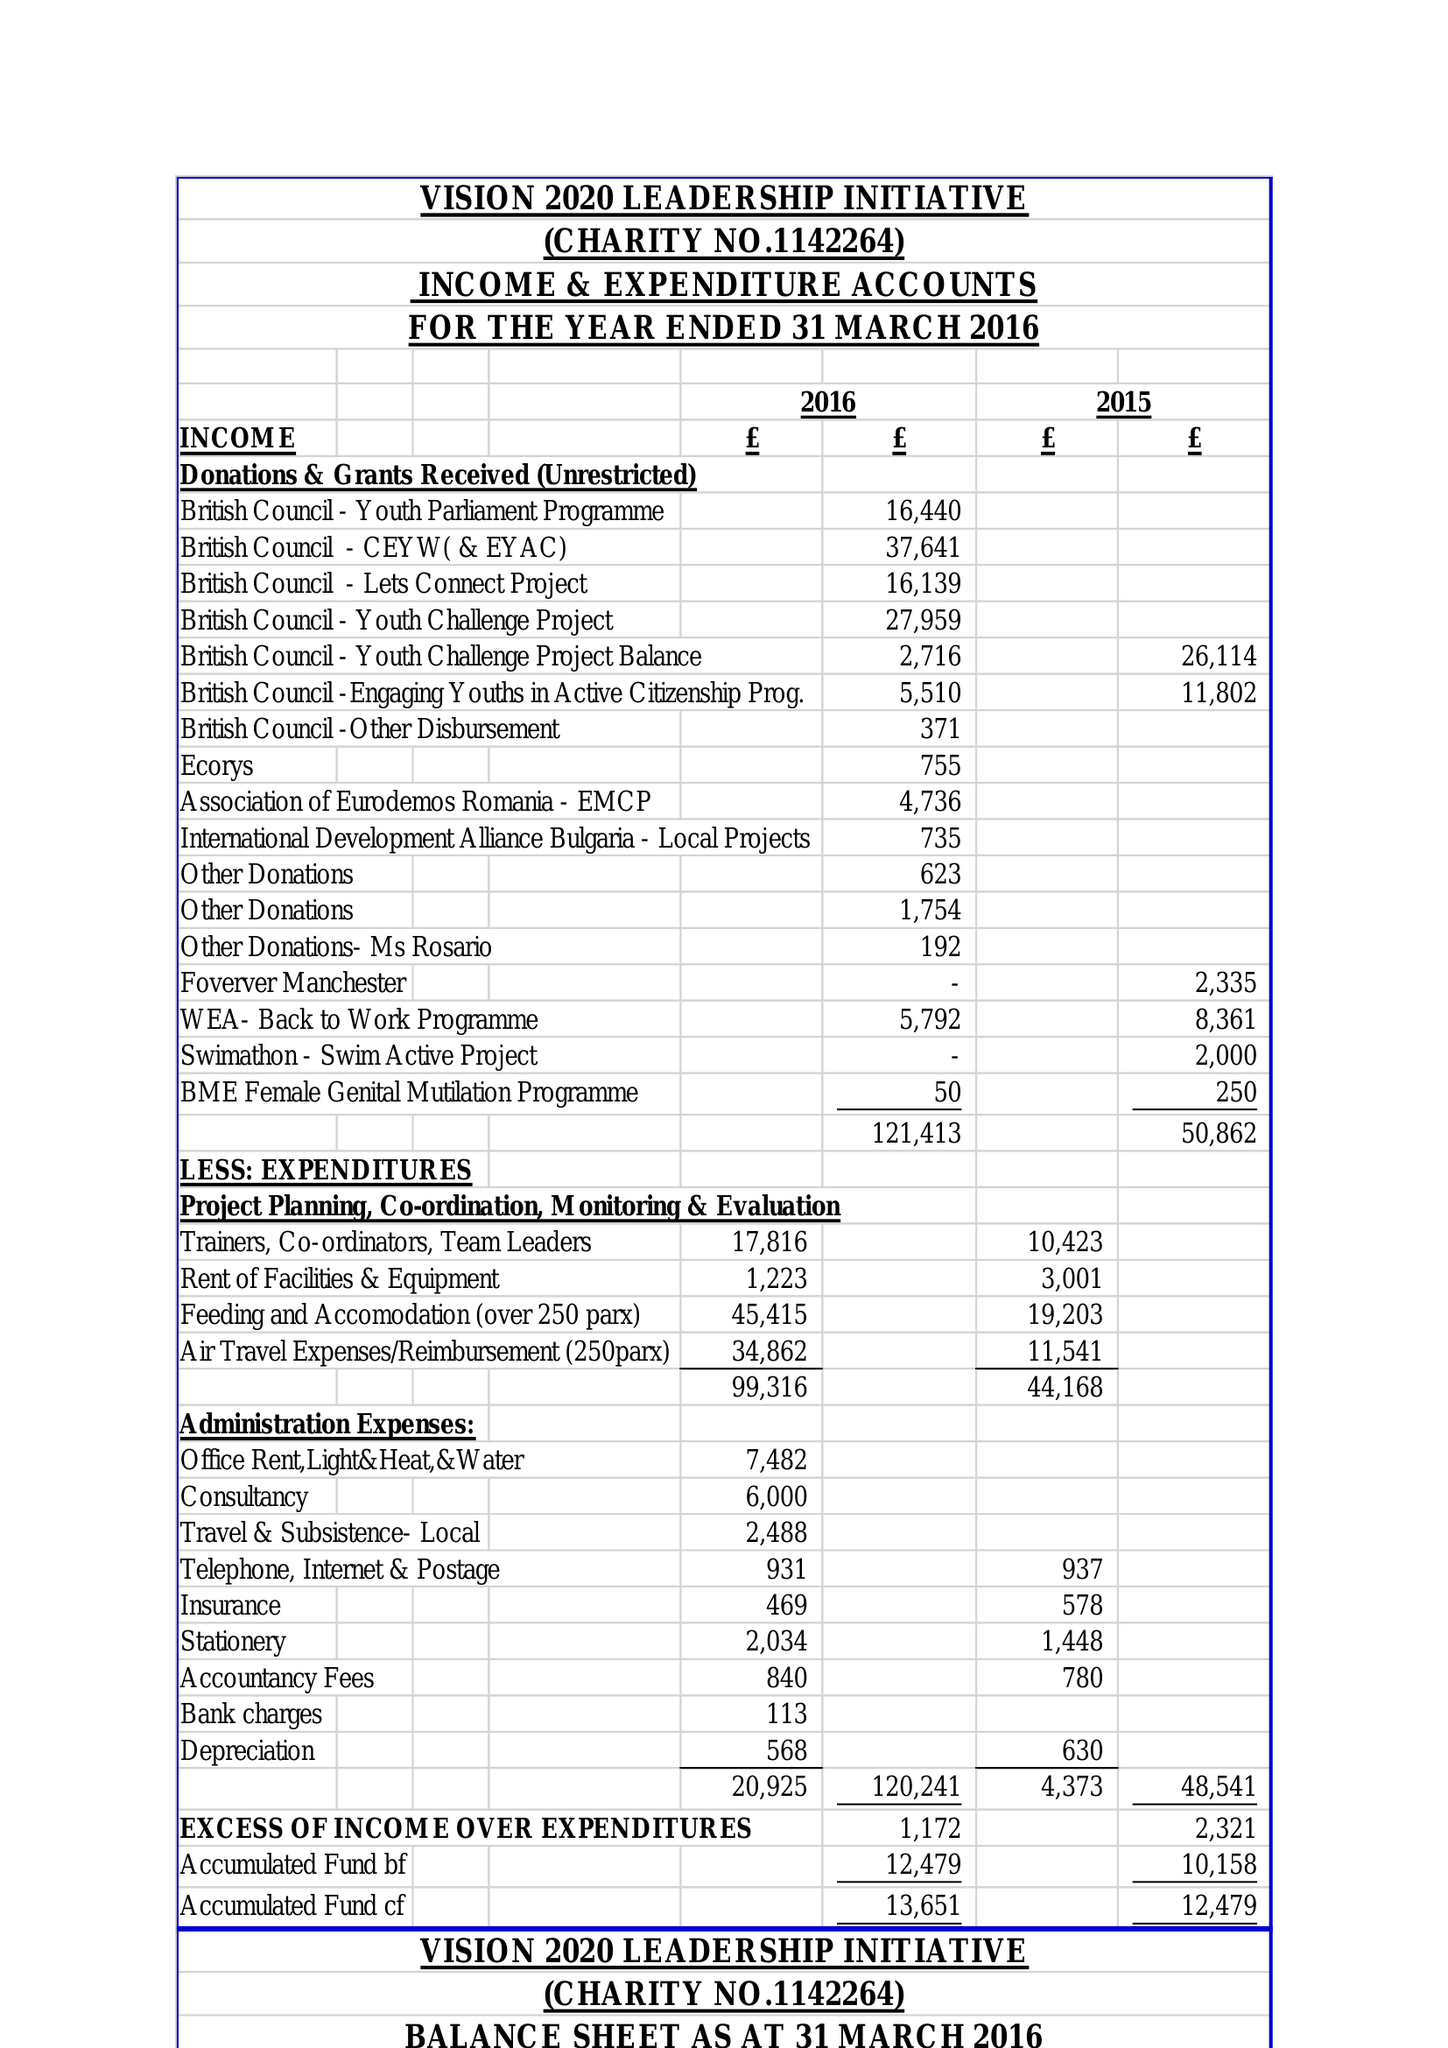What is the value for the address__street_line?
Answer the question using a single word or phrase. 4 FALLOW AVENUE 